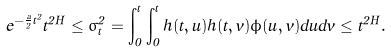<formula> <loc_0><loc_0><loc_500><loc_500>e ^ { - \frac { a } 2 t ^ { 2 } } t ^ { 2 H } \leq \sigma _ { t } ^ { 2 } = \int _ { 0 } ^ { t } \int _ { 0 } ^ { t } h ( t , u ) h ( t , v ) \phi ( u , v ) d u d v \leq t ^ { 2 H } .</formula> 